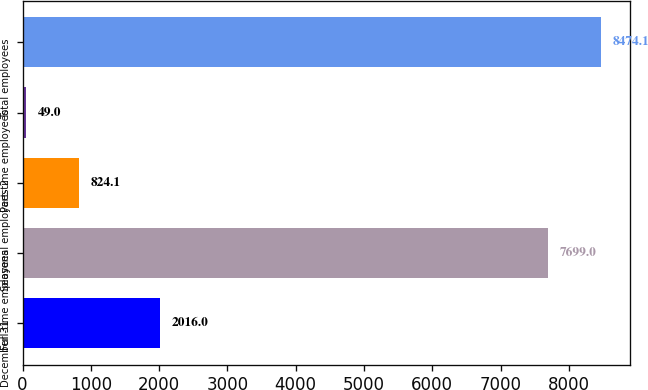Convert chart to OTSL. <chart><loc_0><loc_0><loc_500><loc_500><bar_chart><fcel>December 31<fcel>Full-time employees<fcel>Seasonal employees 2<fcel>Part-time employees<fcel>Total employees<nl><fcel>2016<fcel>7699<fcel>824.1<fcel>49<fcel>8474.1<nl></chart> 